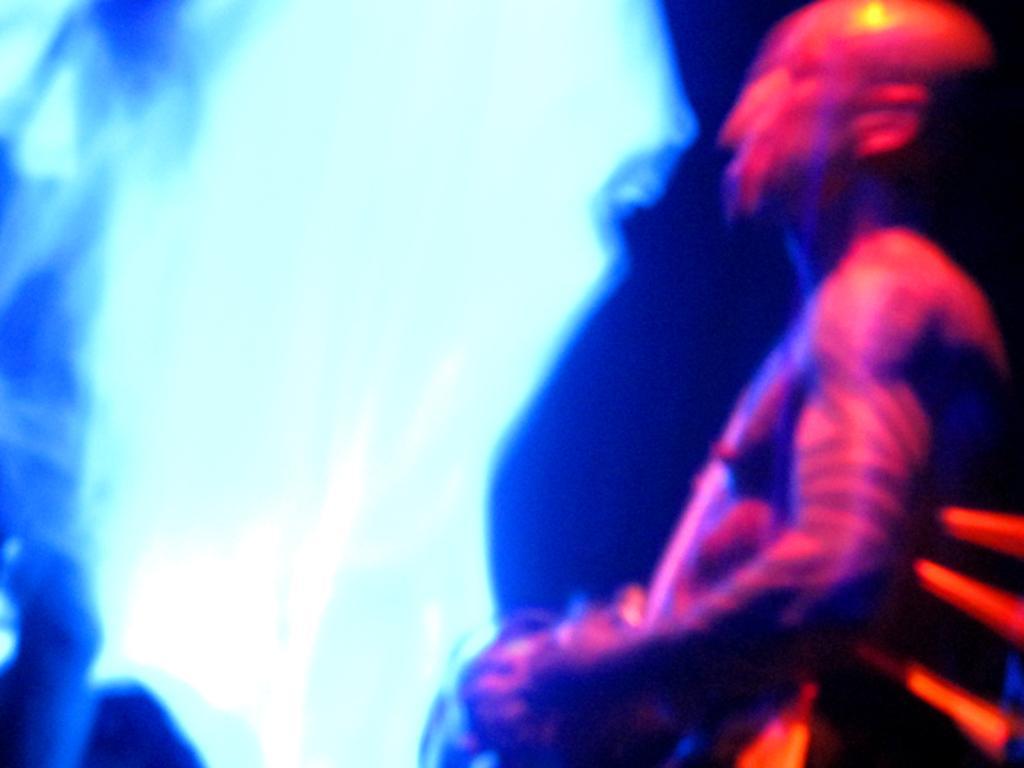How would you summarize this image in a sentence or two? This image is with light effects and on the right, we can see a person standing and holding an object. 